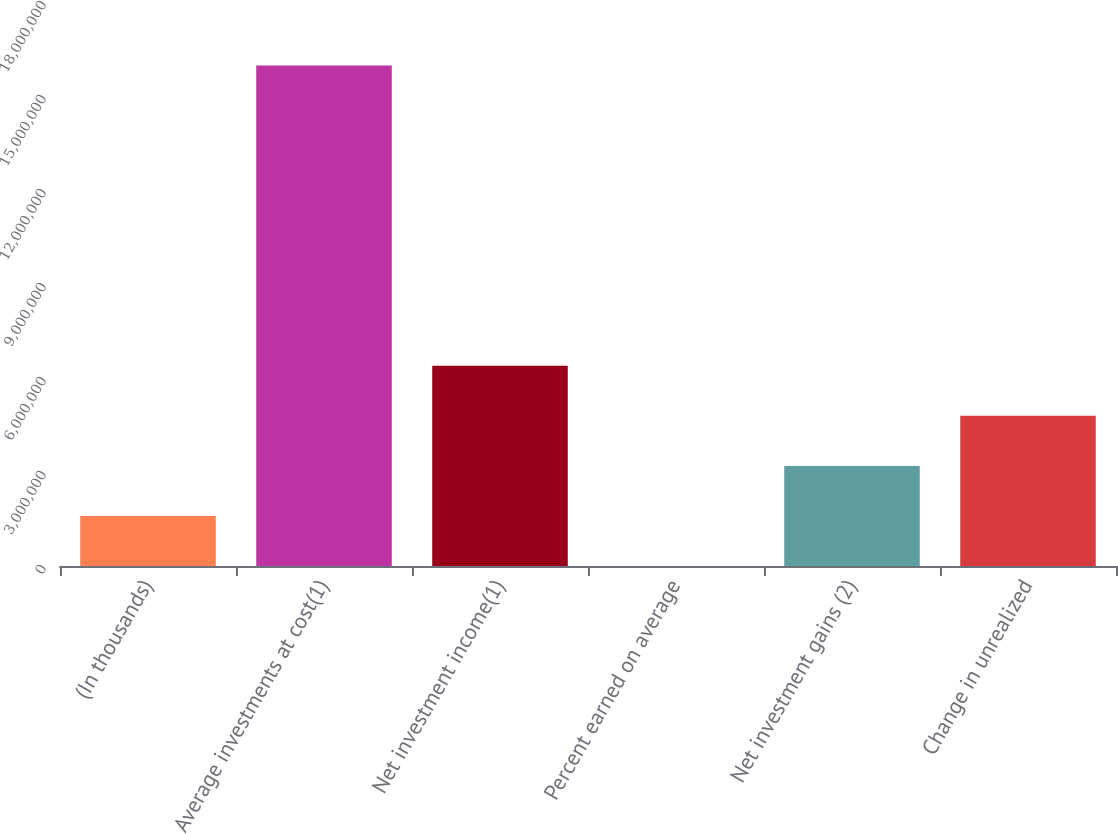Convert chart to OTSL. <chart><loc_0><loc_0><loc_500><loc_500><bar_chart><fcel>(In thousands)<fcel>Average investments at cost(1)<fcel>Net investment income(1)<fcel>Percent earned on average<fcel>Net investment gains (2)<fcel>Change in unrealized<nl><fcel>1.5971e+06<fcel>1.59709e+07<fcel>6.38837e+06<fcel>3.2<fcel>3.19419e+06<fcel>4.79128e+06<nl></chart> 